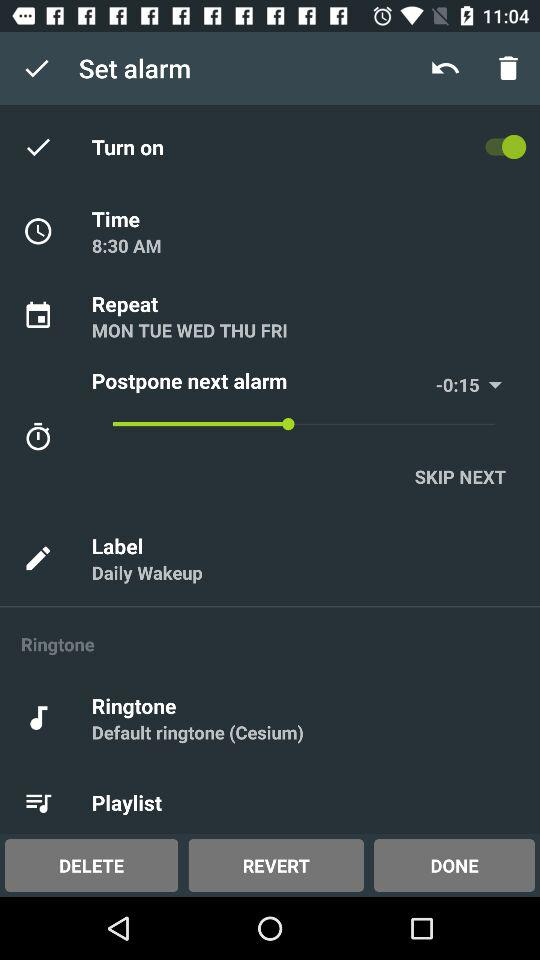Which day's repeated alarm is on? The repeated alarm is on for Monday, Tuesday, Wednesday, Thursday, and Friday. 